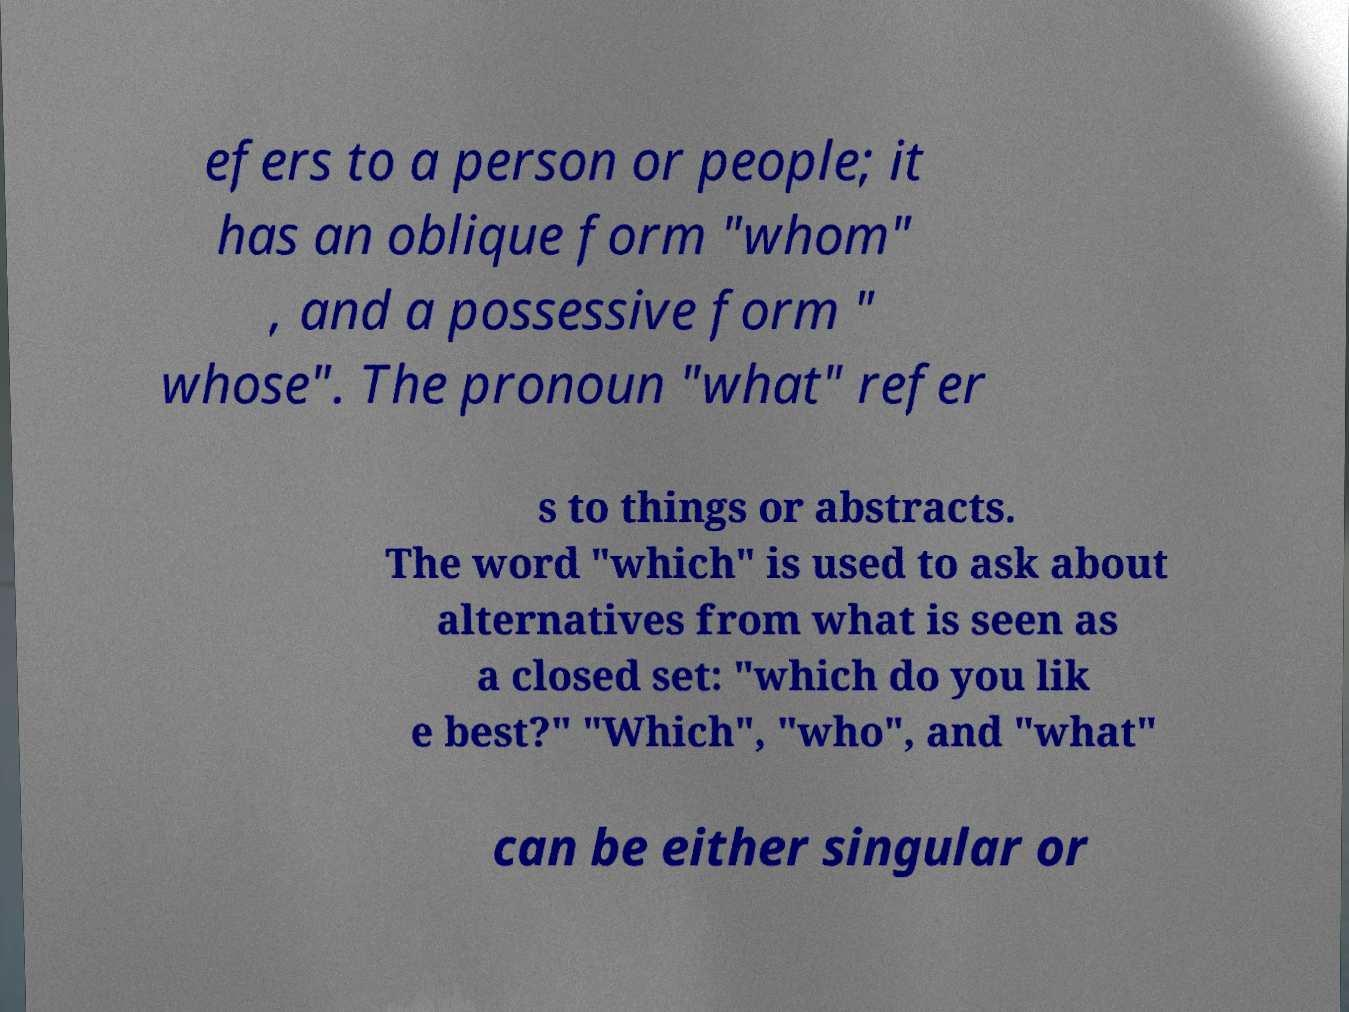Can you read and provide the text displayed in the image?This photo seems to have some interesting text. Can you extract and type it out for me? efers to a person or people; it has an oblique form "whom" , and a possessive form " whose". The pronoun "what" refer s to things or abstracts. The word "which" is used to ask about alternatives from what is seen as a closed set: "which do you lik e best?" "Which", "who", and "what" can be either singular or 